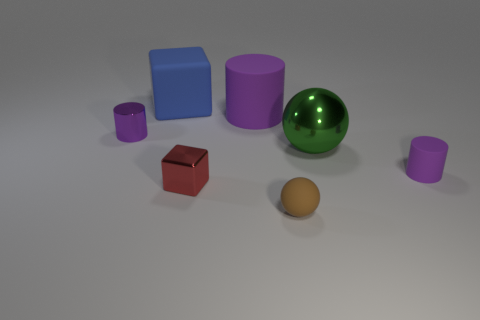Subtract all purple cylinders. How many were subtracted if there are1purple cylinders left? 2 Add 3 small blue rubber spheres. How many objects exist? 10 Subtract all cubes. How many objects are left? 5 Add 7 large metallic objects. How many large metallic objects exist? 8 Subtract 1 brown spheres. How many objects are left? 6 Subtract all tiny red metal things. Subtract all small purple things. How many objects are left? 4 Add 1 big green objects. How many big green objects are left? 2 